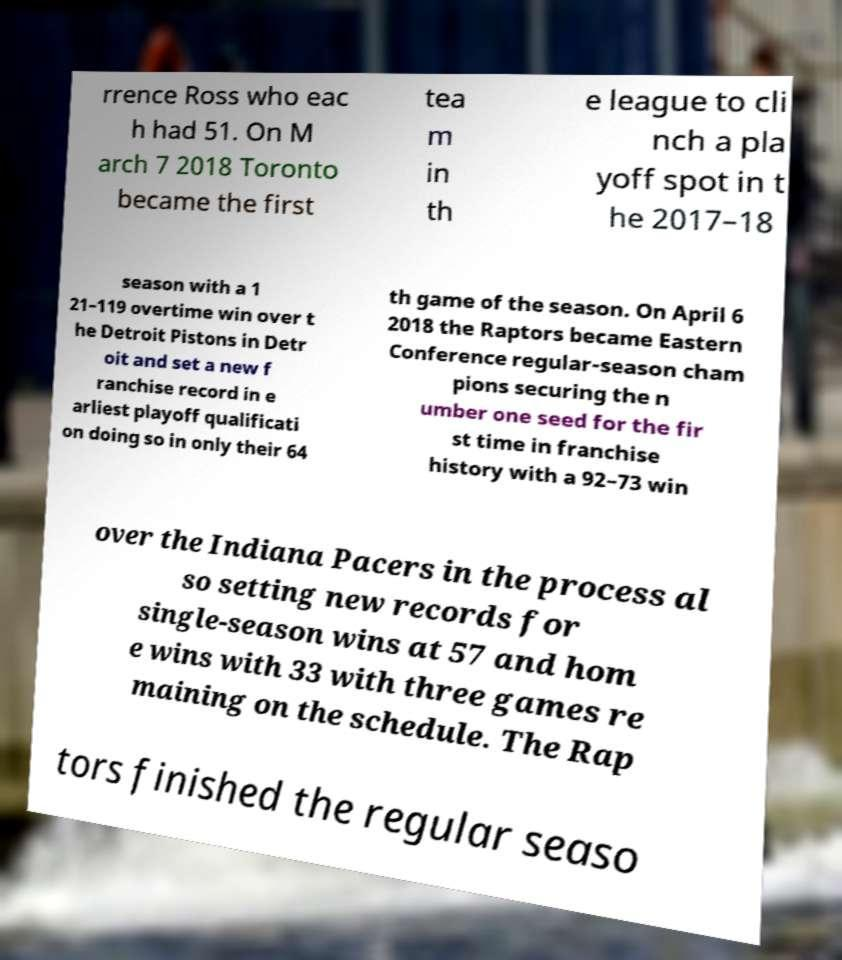Could you extract and type out the text from this image? rrence Ross who eac h had 51. On M arch 7 2018 Toronto became the first tea m in th e league to cli nch a pla yoff spot in t he 2017–18 season with a 1 21–119 overtime win over t he Detroit Pistons in Detr oit and set a new f ranchise record in e arliest playoff qualificati on doing so in only their 64 th game of the season. On April 6 2018 the Raptors became Eastern Conference regular-season cham pions securing the n umber one seed for the fir st time in franchise history with a 92–73 win over the Indiana Pacers in the process al so setting new records for single-season wins at 57 and hom e wins with 33 with three games re maining on the schedule. The Rap tors finished the regular seaso 